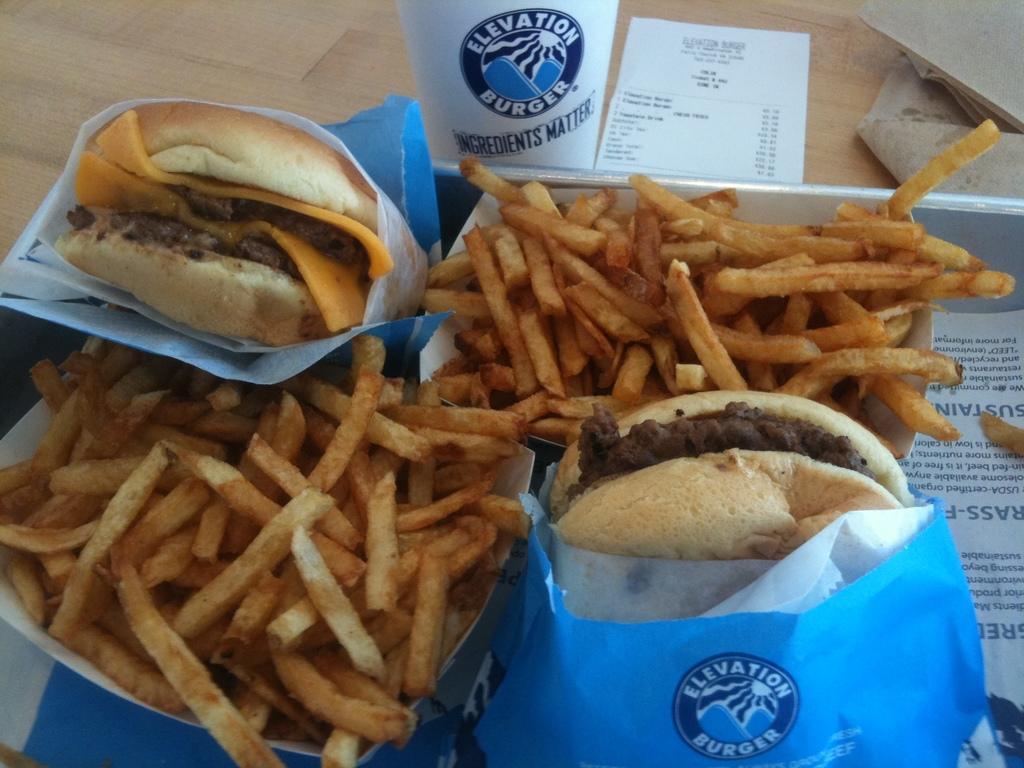Can you describe this image briefly? In this image we can see some food on the paper covers on the plate, one paper with text on the plate, one paper with text and numbers on the table. There are some objects on the table. 